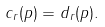<formula> <loc_0><loc_0><loc_500><loc_500>c _ { r } ( p ) = d _ { r } ( p ) .</formula> 